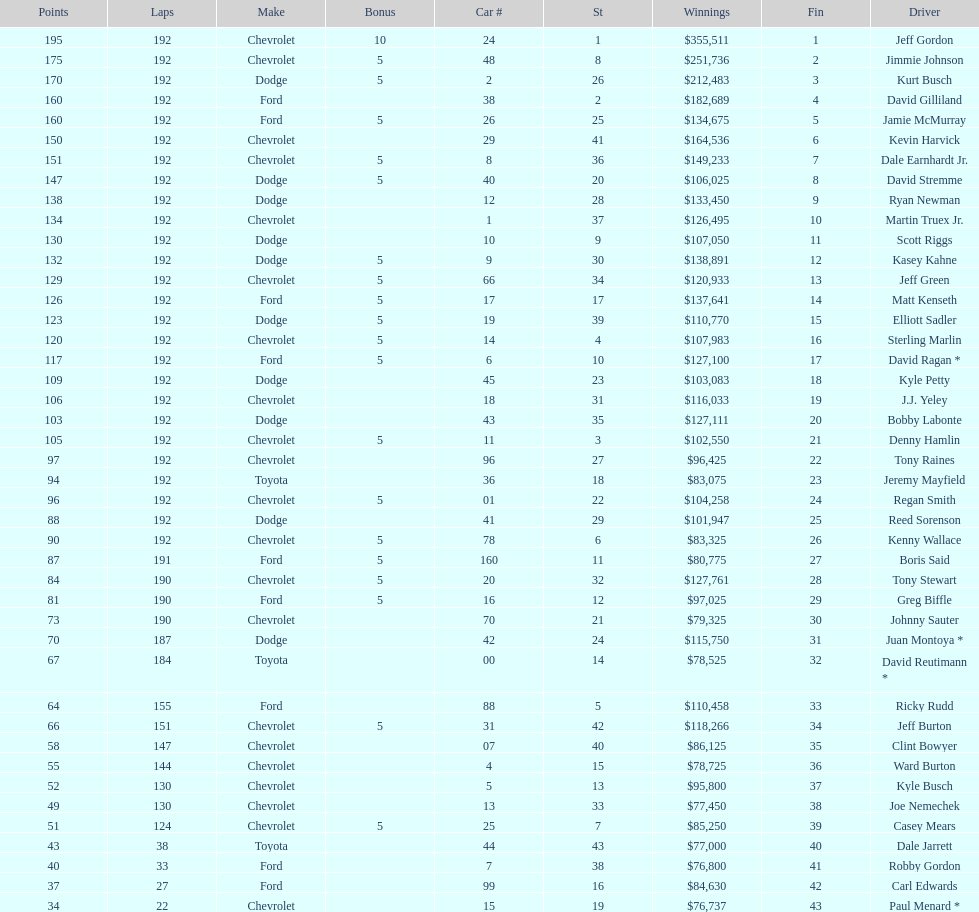Who got the most bonus points? Jeff Gordon. 